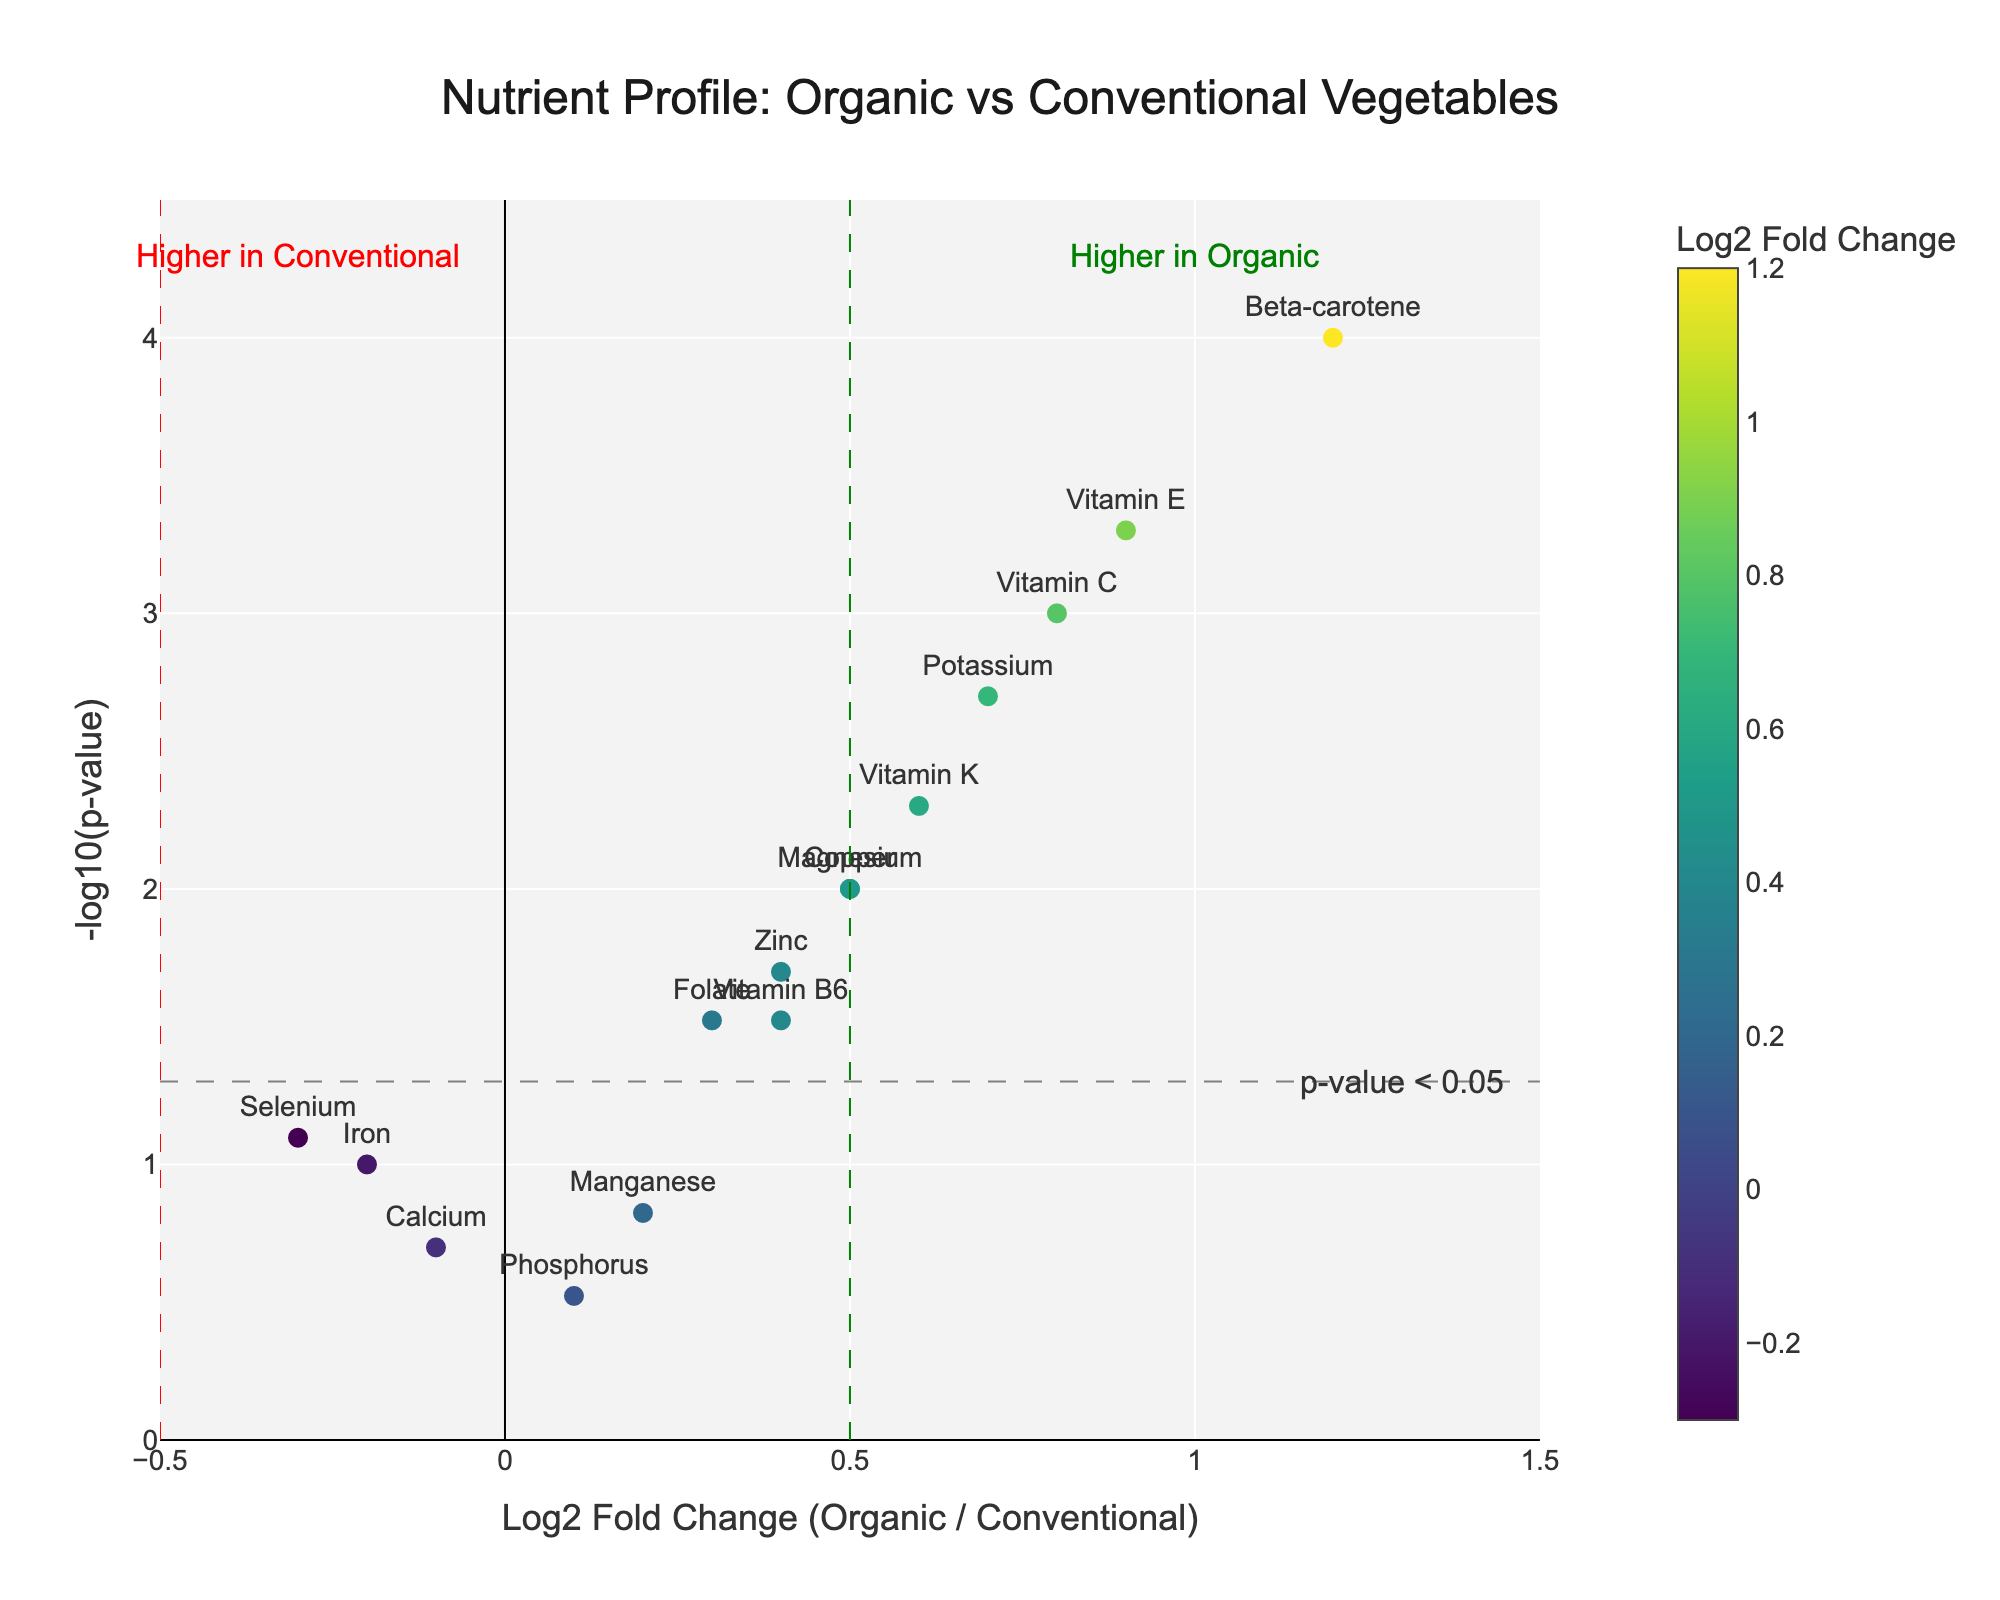What is the title of the figure? The title is displayed at the top of the plot, typically in a larger and prominent font. It reads "Nutrient Profile: Organic vs Conventional Vegetables."
Answer: Nutrient Profile: Organic vs Conventional Vegetables Which nutrient has the highest Log2 Fold Change and how significant is it? Beta-carotene has the highest Log2 Fold Change of 1.2. The significance level can be determined by the p-value, which is shown on the hover text or can be inferred from the -log10(p-value) on the y-axis. The p-value for Beta-carotene is 0.0001, indicating high significance.
Answer: Beta-carotene, 0.0001 How are the p-values visualized in the plot? The p-values are visualized on the y-axis as -log10(p-value). A higher y-value means a lower (more significant) p-value. This transformation makes it easier to visualize small p-values distinctly as larger values on the plot.
Answer: As -log10(p-value) on the y-axis Which nutrients have a Log2 Fold Change greater than 0.5 and a p-value below 0.05? To answer this, we look for points with Log2 Fold Change (x-axis) greater than 0.5 and -log10(p-value) (y-axis) above a certain threshold representing p<0.05. The nutrients fulfilling these criteria are Vitamin C, Vitamin K, Beta-carotene, Vitamin E, Potassium, and Copper.
Answer: Vitamin C, Vitamin K, Beta-carotene, Vitamin E, Potassium, Copper What does the vertical line at 0.5 on the x-axis represent? The vertical line at 0.5 on the x-axis represents a log2 fold change threshold. Anything to the right of this line indicates nutrients that are significantly higher in organic vegetables compared to conventional ones.
Answer: Threshold for higher nutrients in organic Which nutrients are higher in conventional vegetables, indicated by a negative Log2 Fold Change? Nutrients with a negative Log2 Fold Change are positioned to the left of the vertical axis (x=0). Iron, Calcium, and Selenium have negative Log2 Fold Change values, indicating higher concentrations in conventional vegetables.
Answer: Iron, Calcium, Selenium Why are Vitamin C and Vitamin E considered statistically significant? They are considered statistically significant because they fall above the horizontal line representing the -log10(0.05) threshold and to the right of the 0.5 Log2 Fold Change line. Their p-values are 0.001 and 0.0005 respectively, both well below 0.05.
Answer: p-value < 0.05, high log2 fold change Which side of the plot represents nutrients higher in organic vegetables and how can you tell? The right side of the plot (positive Log2 Fold Change) represents nutrients higher in organic vegetables. This is indicated by the annotations and the vertical line at x=0.5 showing the threshold for higher content in organic vegetables.
Answer: Right side (positive Log2 Fold Change) How many nutrients have a p-value below 0.05? Nutrients with a p-value below 0.05 are those above the horizontal line representing -log10(0.05). By examining the plot, we see there are 10 nutrients above this line.
Answer: 10 